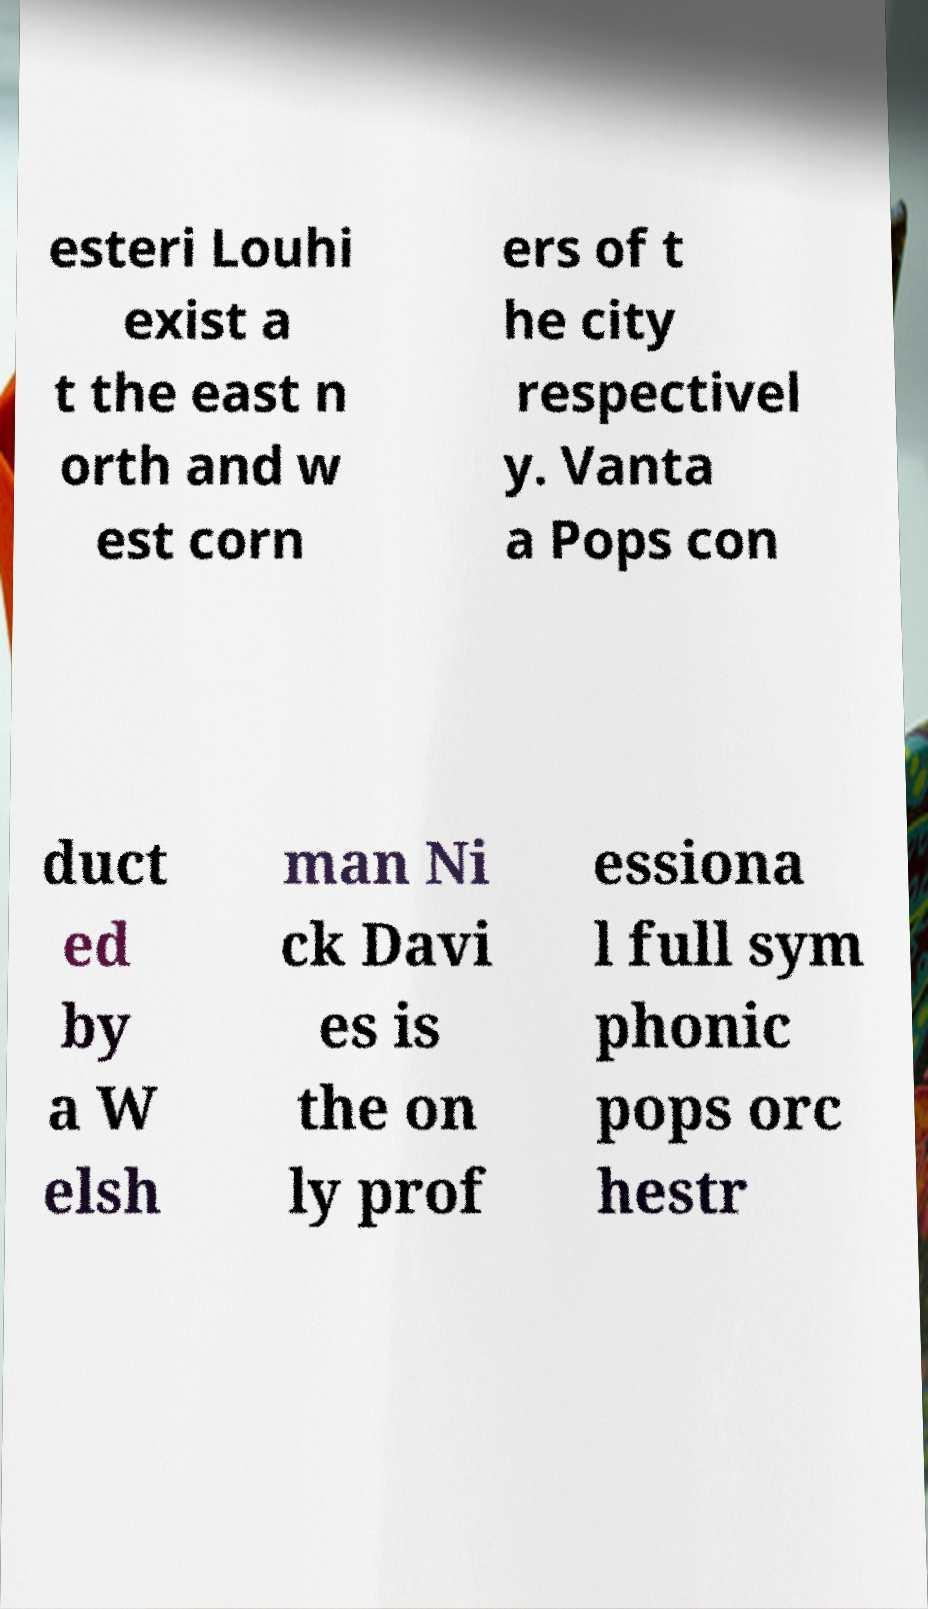Can you read and provide the text displayed in the image?This photo seems to have some interesting text. Can you extract and type it out for me? esteri Louhi exist a t the east n orth and w est corn ers of t he city respectivel y. Vanta a Pops con duct ed by a W elsh man Ni ck Davi es is the on ly prof essiona l full sym phonic pops orc hestr 